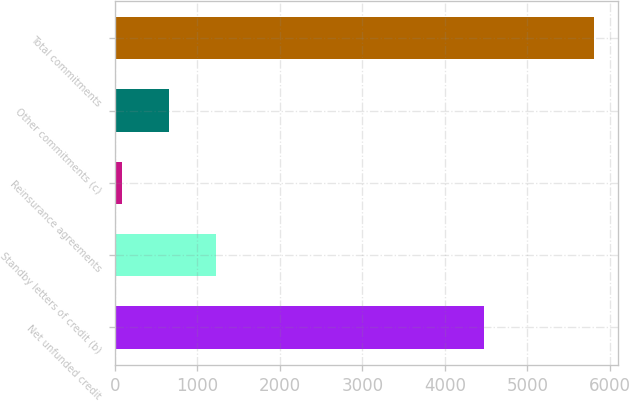Convert chart to OTSL. <chart><loc_0><loc_0><loc_500><loc_500><bar_chart><fcel>Net unfunded credit<fcel>Standby letters of credit (b)<fcel>Reinsurance agreements<fcel>Other commitments (c)<fcel>Total commitments<nl><fcel>4476<fcel>1229.2<fcel>86<fcel>657.6<fcel>5802<nl></chart> 